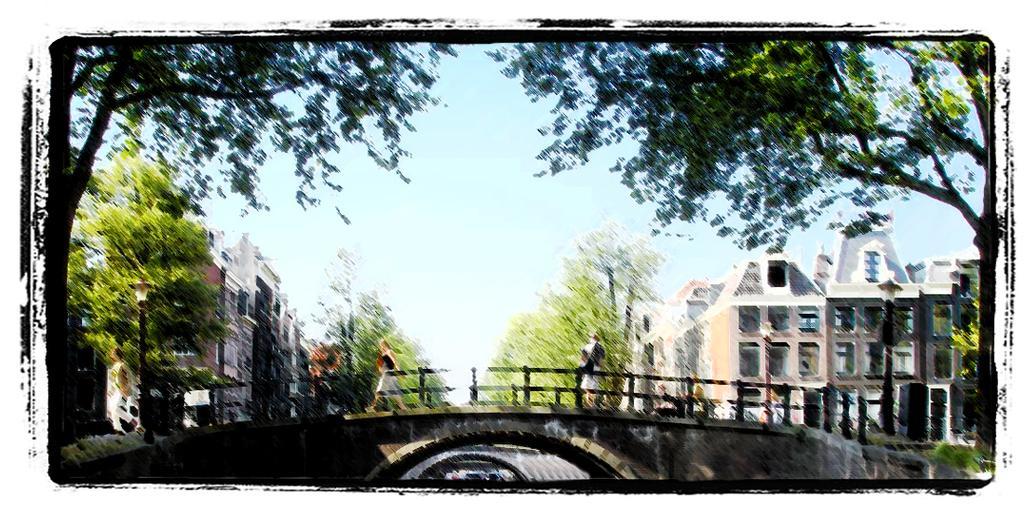Describe this image in one or two sentences. This picture shows a painting. We see few buildings and trees and few of them walking on the bridge and a blue sky. 